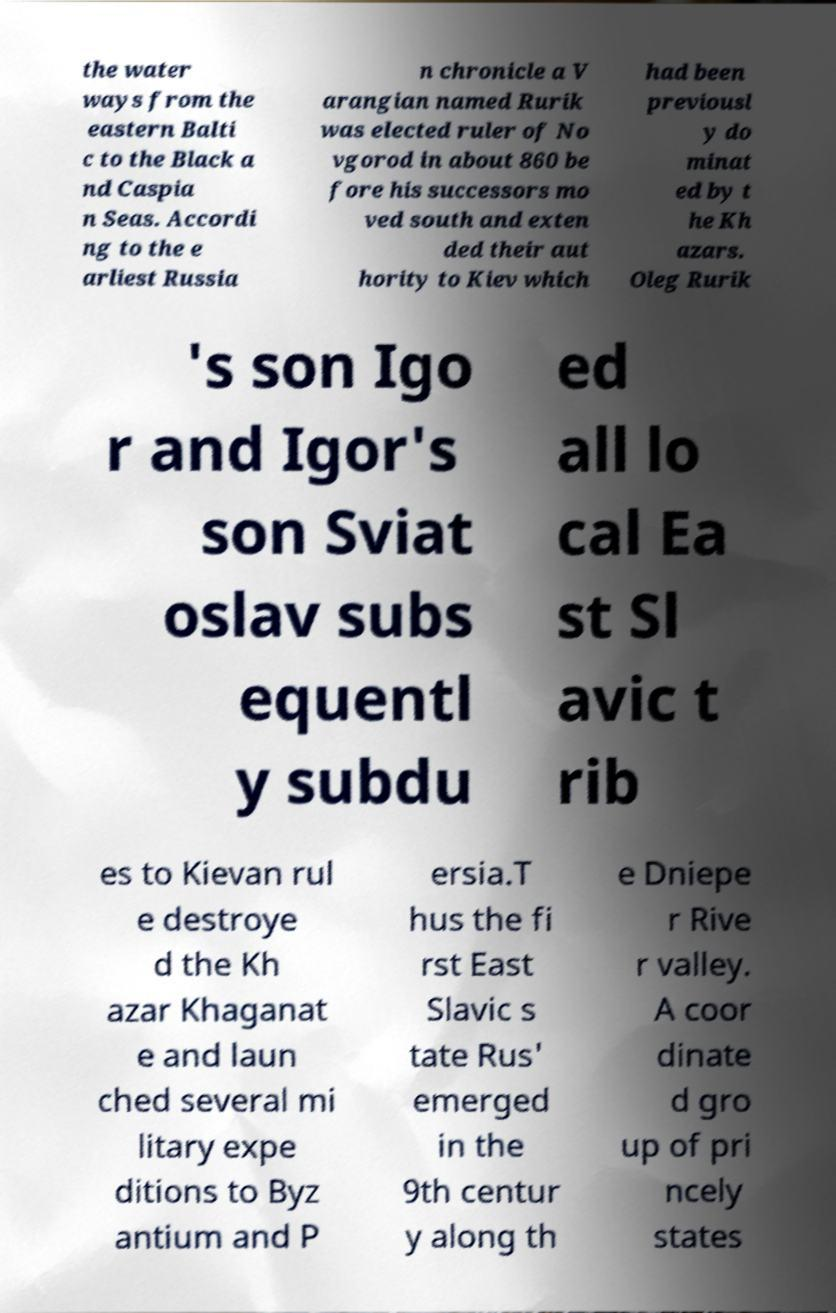Please read and relay the text visible in this image. What does it say? the water ways from the eastern Balti c to the Black a nd Caspia n Seas. Accordi ng to the e arliest Russia n chronicle a V arangian named Rurik was elected ruler of No vgorod in about 860 be fore his successors mo ved south and exten ded their aut hority to Kiev which had been previousl y do minat ed by t he Kh azars. Oleg Rurik 's son Igo r and Igor's son Sviat oslav subs equentl y subdu ed all lo cal Ea st Sl avic t rib es to Kievan rul e destroye d the Kh azar Khaganat e and laun ched several mi litary expe ditions to Byz antium and P ersia.T hus the fi rst East Slavic s tate Rus' emerged in the 9th centur y along th e Dniepe r Rive r valley. A coor dinate d gro up of pri ncely states 